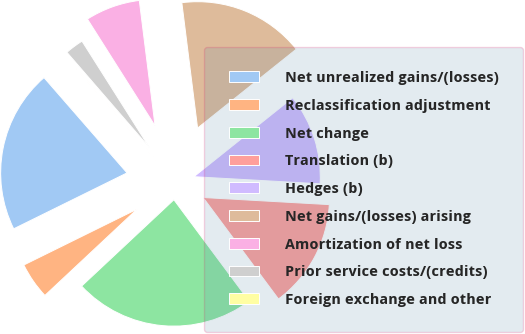Convert chart to OTSL. <chart><loc_0><loc_0><loc_500><loc_500><pie_chart><fcel>Net unrealized gains/(losses)<fcel>Reclassification adjustment<fcel>Net change<fcel>Translation (b)<fcel>Hedges (b)<fcel>Net gains/(losses) arising<fcel>Amortization of net loss<fcel>Prior service costs/(credits)<fcel>Foreign exchange and other<nl><fcel>20.89%<fcel>4.68%<fcel>23.2%<fcel>13.94%<fcel>11.63%<fcel>16.26%<fcel>7.0%<fcel>2.37%<fcel>0.05%<nl></chart> 